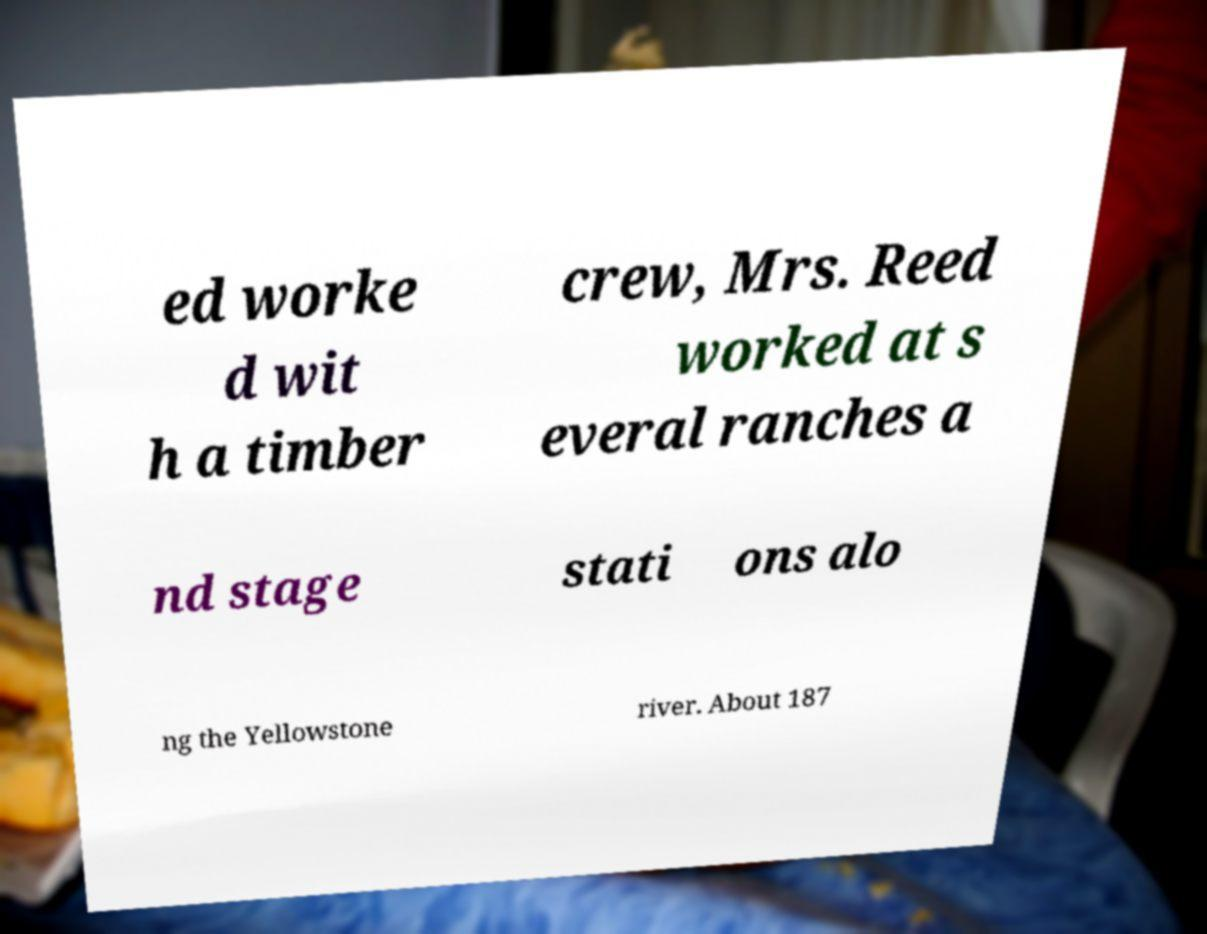I need the written content from this picture converted into text. Can you do that? ed worke d wit h a timber crew, Mrs. Reed worked at s everal ranches a nd stage stati ons alo ng the Yellowstone river. About 187 